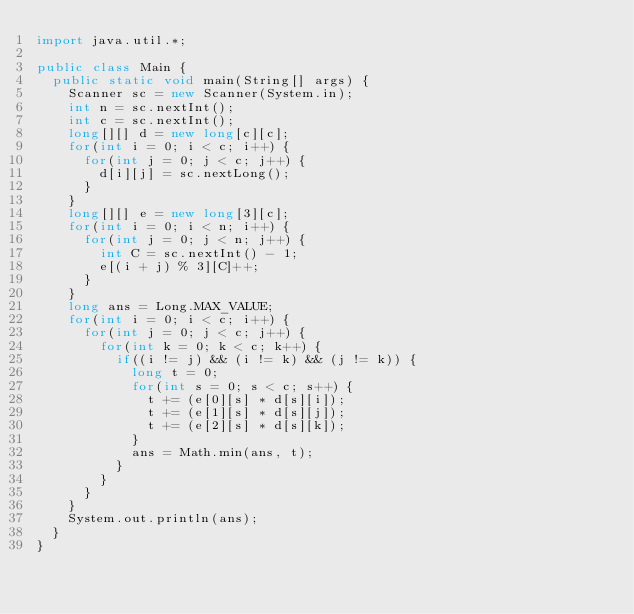<code> <loc_0><loc_0><loc_500><loc_500><_Java_>import java.util.*;

public class Main {
  public static void main(String[] args) {
    Scanner sc = new Scanner(System.in);
    int n = sc.nextInt();
    int c = sc.nextInt();
    long[][] d = new long[c][c];
    for(int i = 0; i < c; i++) {
      for(int j = 0; j < c; j++) {
        d[i][j] = sc.nextLong();
      }
    }
    long[][] e = new long[3][c];
    for(int i = 0; i < n; i++) {
      for(int j = 0; j < n; j++) {
        int C = sc.nextInt() - 1;
        e[(i + j) % 3][C]++;
      }
    }
    long ans = Long.MAX_VALUE;
    for(int i = 0; i < c; i++) {
      for(int j = 0; j < c; j++) {
        for(int k = 0; k < c; k++) {
          if((i != j) && (i != k) && (j != k)) {
            long t = 0;
            for(int s = 0; s < c; s++) {
              t += (e[0][s] * d[s][i]);
              t += (e[1][s] * d[s][j]);
              t += (e[2][s] * d[s][k]);
            }
            ans = Math.min(ans, t);
          }
        }
      }
    }
    System.out.println(ans);
  }
}</code> 